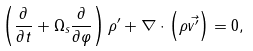Convert formula to latex. <formula><loc_0><loc_0><loc_500><loc_500>\left ( \frac { \partial } { \partial t } + \Omega _ { s } \frac { \partial } { \partial \varphi } \right ) \rho ^ { \prime } + \nabla \cdot \left ( \rho \vec { v ^ { \prime } } \right ) = 0 ,</formula> 